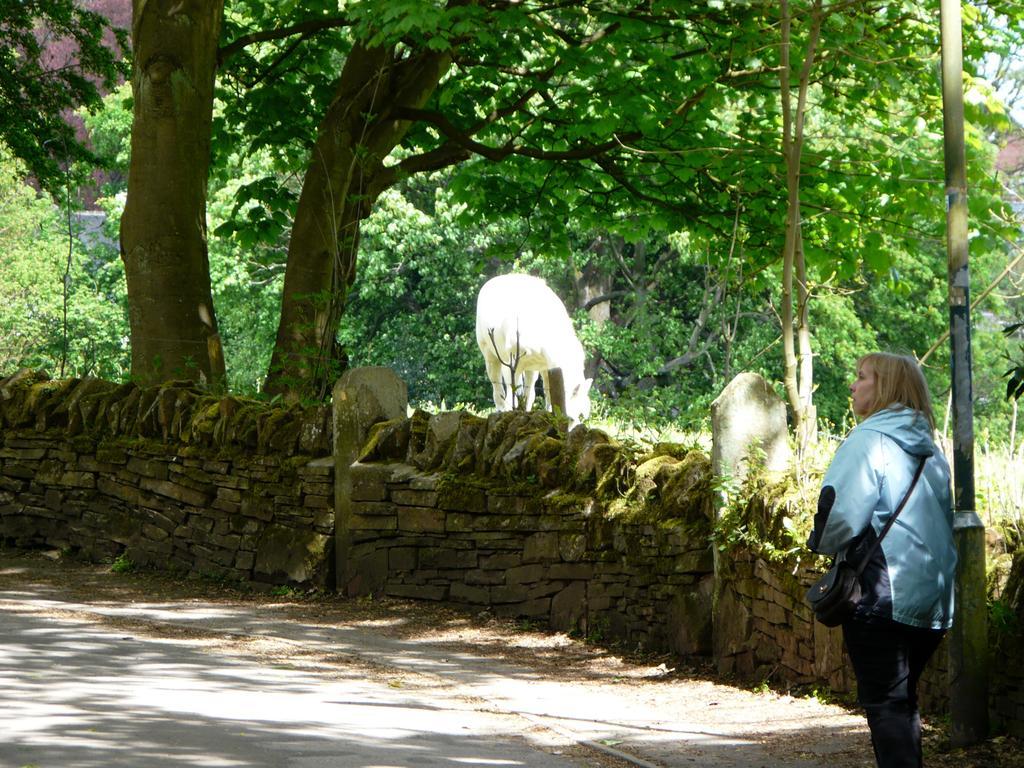Can you describe this image briefly? In this image there are two animals which are eating the grass on the ground. On the right side there is a woman who is wearing the bag is walking on the road. Beside her there is a stone wall. In the background there are trees. On the right side there is a pole. 